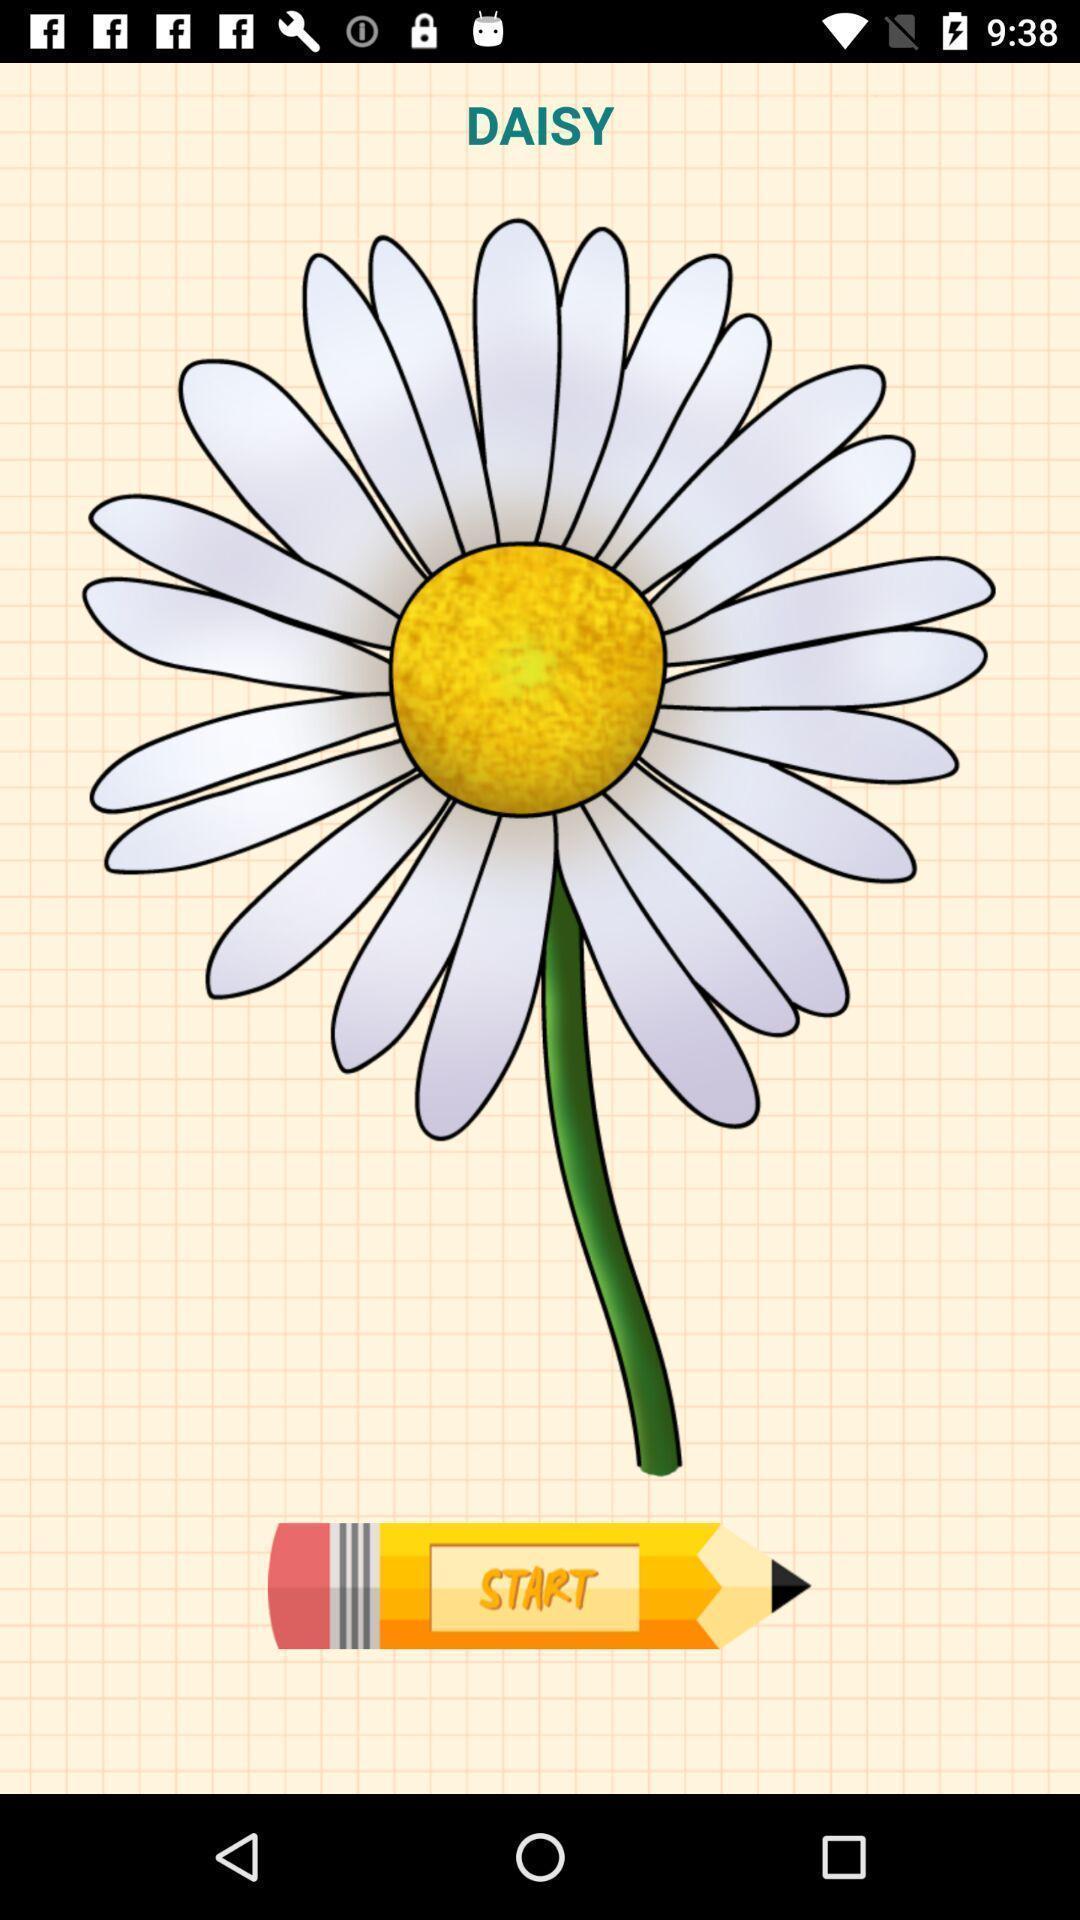Give me a summary of this screen capture. Welcome page with a flower image. 